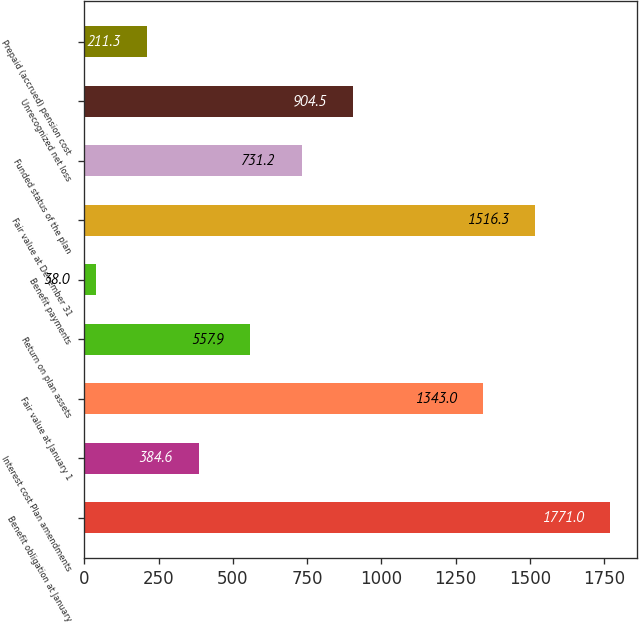<chart> <loc_0><loc_0><loc_500><loc_500><bar_chart><fcel>Benefit obligation at January<fcel>Interest cost Plan amendments<fcel>Fair value at January 1<fcel>Return on plan assets<fcel>Benefit payments<fcel>Fair value at December 31<fcel>Funded status of the plan<fcel>Unrecognized net loss<fcel>Prepaid (accrued) pension cost<nl><fcel>1771<fcel>384.6<fcel>1343<fcel>557.9<fcel>38<fcel>1516.3<fcel>731.2<fcel>904.5<fcel>211.3<nl></chart> 